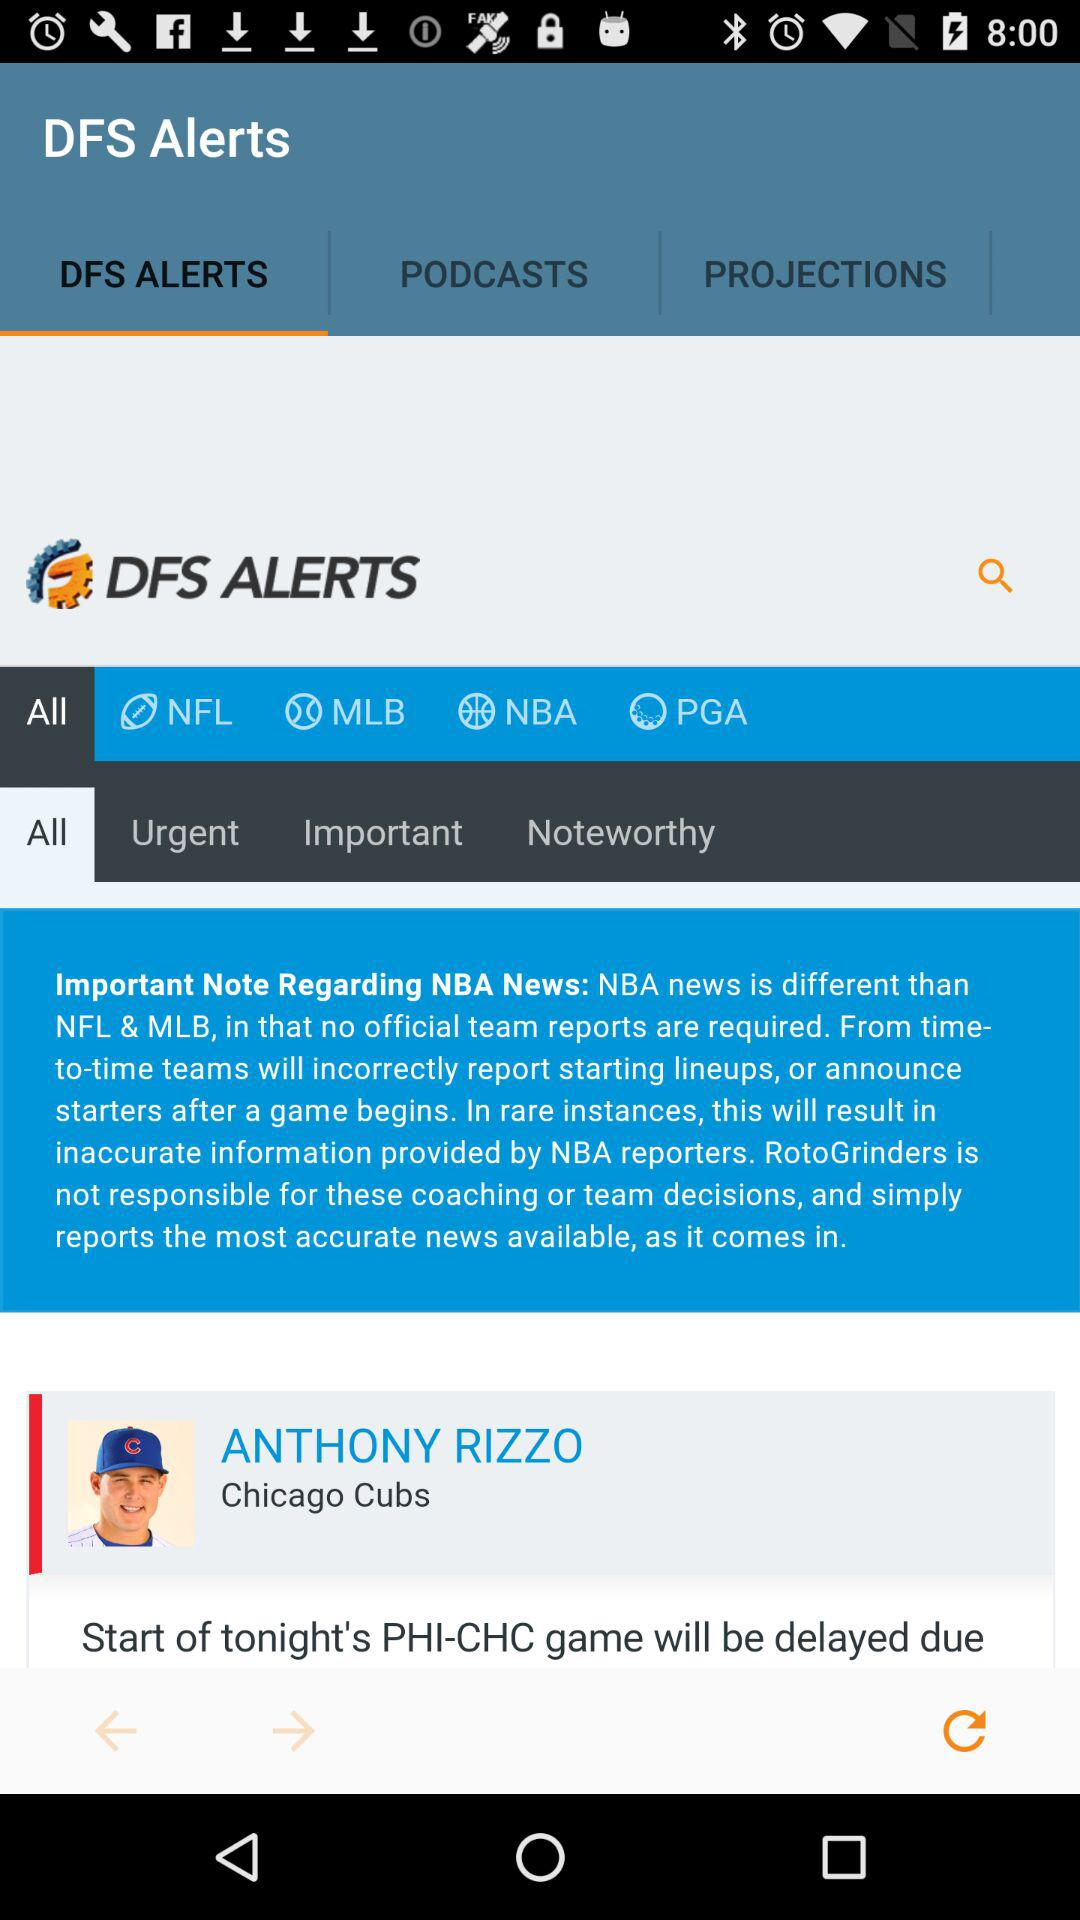Which option is selected? The selected options are "DFS ALERTS" and "All". 